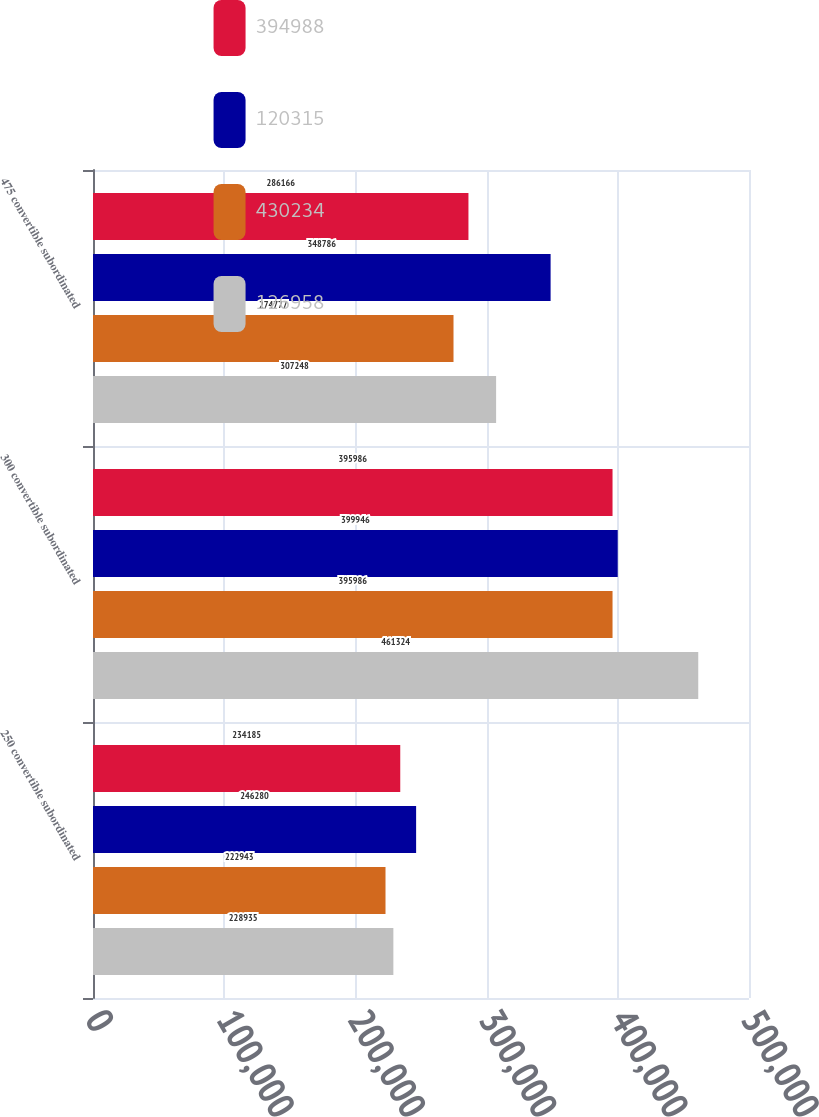Convert chart. <chart><loc_0><loc_0><loc_500><loc_500><stacked_bar_chart><ecel><fcel>250 convertible subordinated<fcel>300 convertible subordinated<fcel>475 convertible subordinated<nl><fcel>394988<fcel>234185<fcel>395986<fcel>286166<nl><fcel>120315<fcel>246280<fcel>399946<fcel>348786<nl><fcel>430234<fcel>222943<fcel>395986<fcel>274777<nl><fcel>126958<fcel>228935<fcel>461324<fcel>307248<nl></chart> 